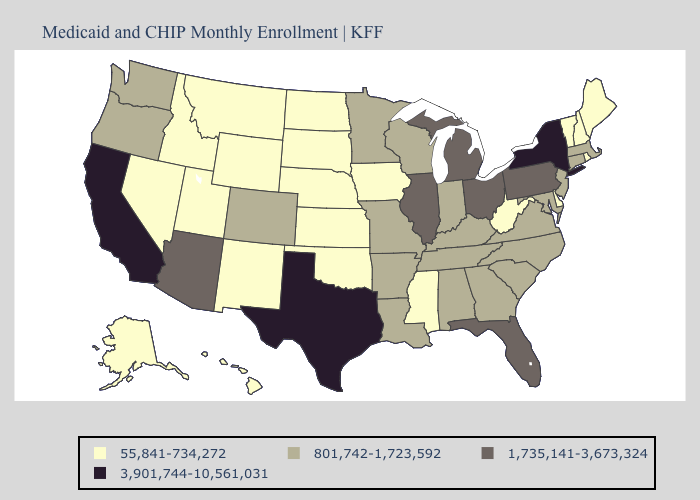Does South Carolina have the lowest value in the South?
Write a very short answer. No. What is the value of Maine?
Be succinct. 55,841-734,272. Does New York have the same value as Tennessee?
Quick response, please. No. Among the states that border Kansas , does Oklahoma have the lowest value?
Short answer required. Yes. What is the highest value in states that border Connecticut?
Be succinct. 3,901,744-10,561,031. How many symbols are there in the legend?
Answer briefly. 4. What is the value of Missouri?
Give a very brief answer. 801,742-1,723,592. Which states hav the highest value in the Northeast?
Short answer required. New York. Name the states that have a value in the range 1,735,141-3,673,324?
Answer briefly. Arizona, Florida, Illinois, Michigan, Ohio, Pennsylvania. What is the value of Louisiana?
Be succinct. 801,742-1,723,592. How many symbols are there in the legend?
Quick response, please. 4. Does Illinois have a higher value than Michigan?
Quick response, please. No. Does California have the highest value in the West?
Keep it brief. Yes. Which states have the lowest value in the USA?
Be succinct. Alaska, Delaware, Hawaii, Idaho, Iowa, Kansas, Maine, Mississippi, Montana, Nebraska, Nevada, New Hampshire, New Mexico, North Dakota, Oklahoma, Rhode Island, South Dakota, Utah, Vermont, West Virginia, Wyoming. 